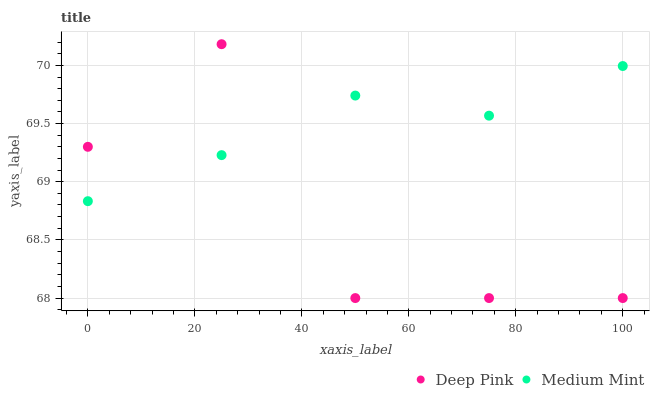Does Deep Pink have the minimum area under the curve?
Answer yes or no. Yes. Does Medium Mint have the maximum area under the curve?
Answer yes or no. Yes. Does Deep Pink have the maximum area under the curve?
Answer yes or no. No. Is Medium Mint the smoothest?
Answer yes or no. Yes. Is Deep Pink the roughest?
Answer yes or no. Yes. Is Deep Pink the smoothest?
Answer yes or no. No. Does Deep Pink have the lowest value?
Answer yes or no. Yes. Does Deep Pink have the highest value?
Answer yes or no. Yes. Does Medium Mint intersect Deep Pink?
Answer yes or no. Yes. Is Medium Mint less than Deep Pink?
Answer yes or no. No. Is Medium Mint greater than Deep Pink?
Answer yes or no. No. 